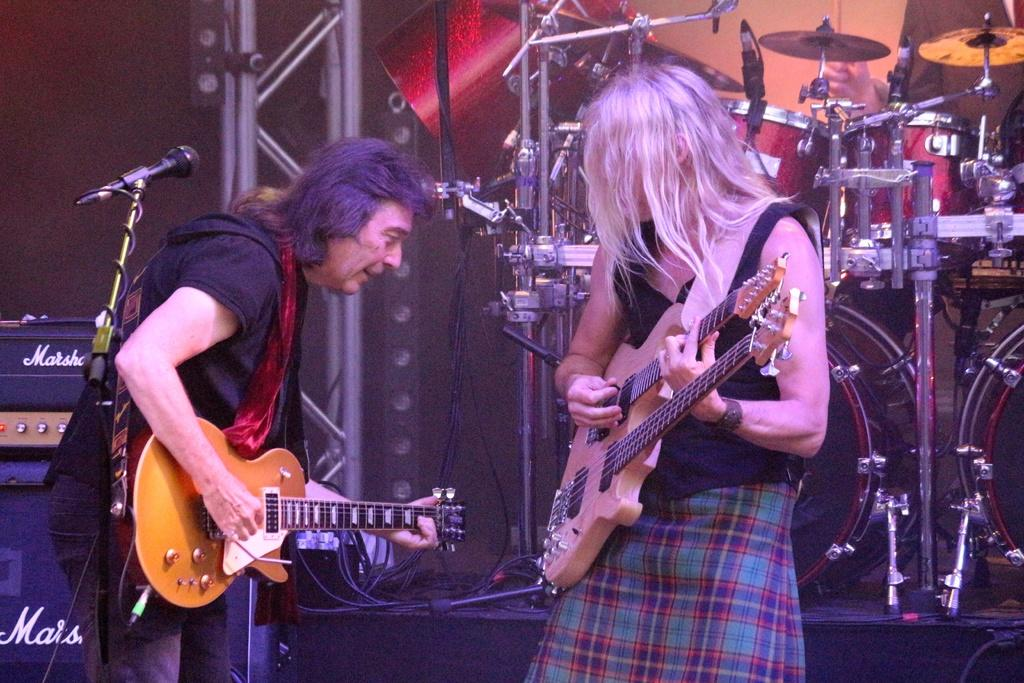How many people are in the image? There are two persons in the image. What are the persons doing in the image? Both persons are playing musical instruments. How many cents can be seen on the floor in the image? There are no cents visible on the floor in the image. What type of coat is the person on the left wearing in the image? There is no coat visible on either person in the image. 